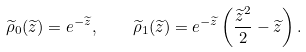Convert formula to latex. <formula><loc_0><loc_0><loc_500><loc_500>\widetilde { \rho } _ { 0 } ( \widetilde { z } ) = e ^ { - \widetilde { z } } , \quad \widetilde { \rho } _ { 1 } ( \widetilde { z } ) = e ^ { - \widetilde { z } } \left ( \frac { \widetilde { z } ^ { 2 } } { 2 } - \widetilde { z } \right ) .</formula> 